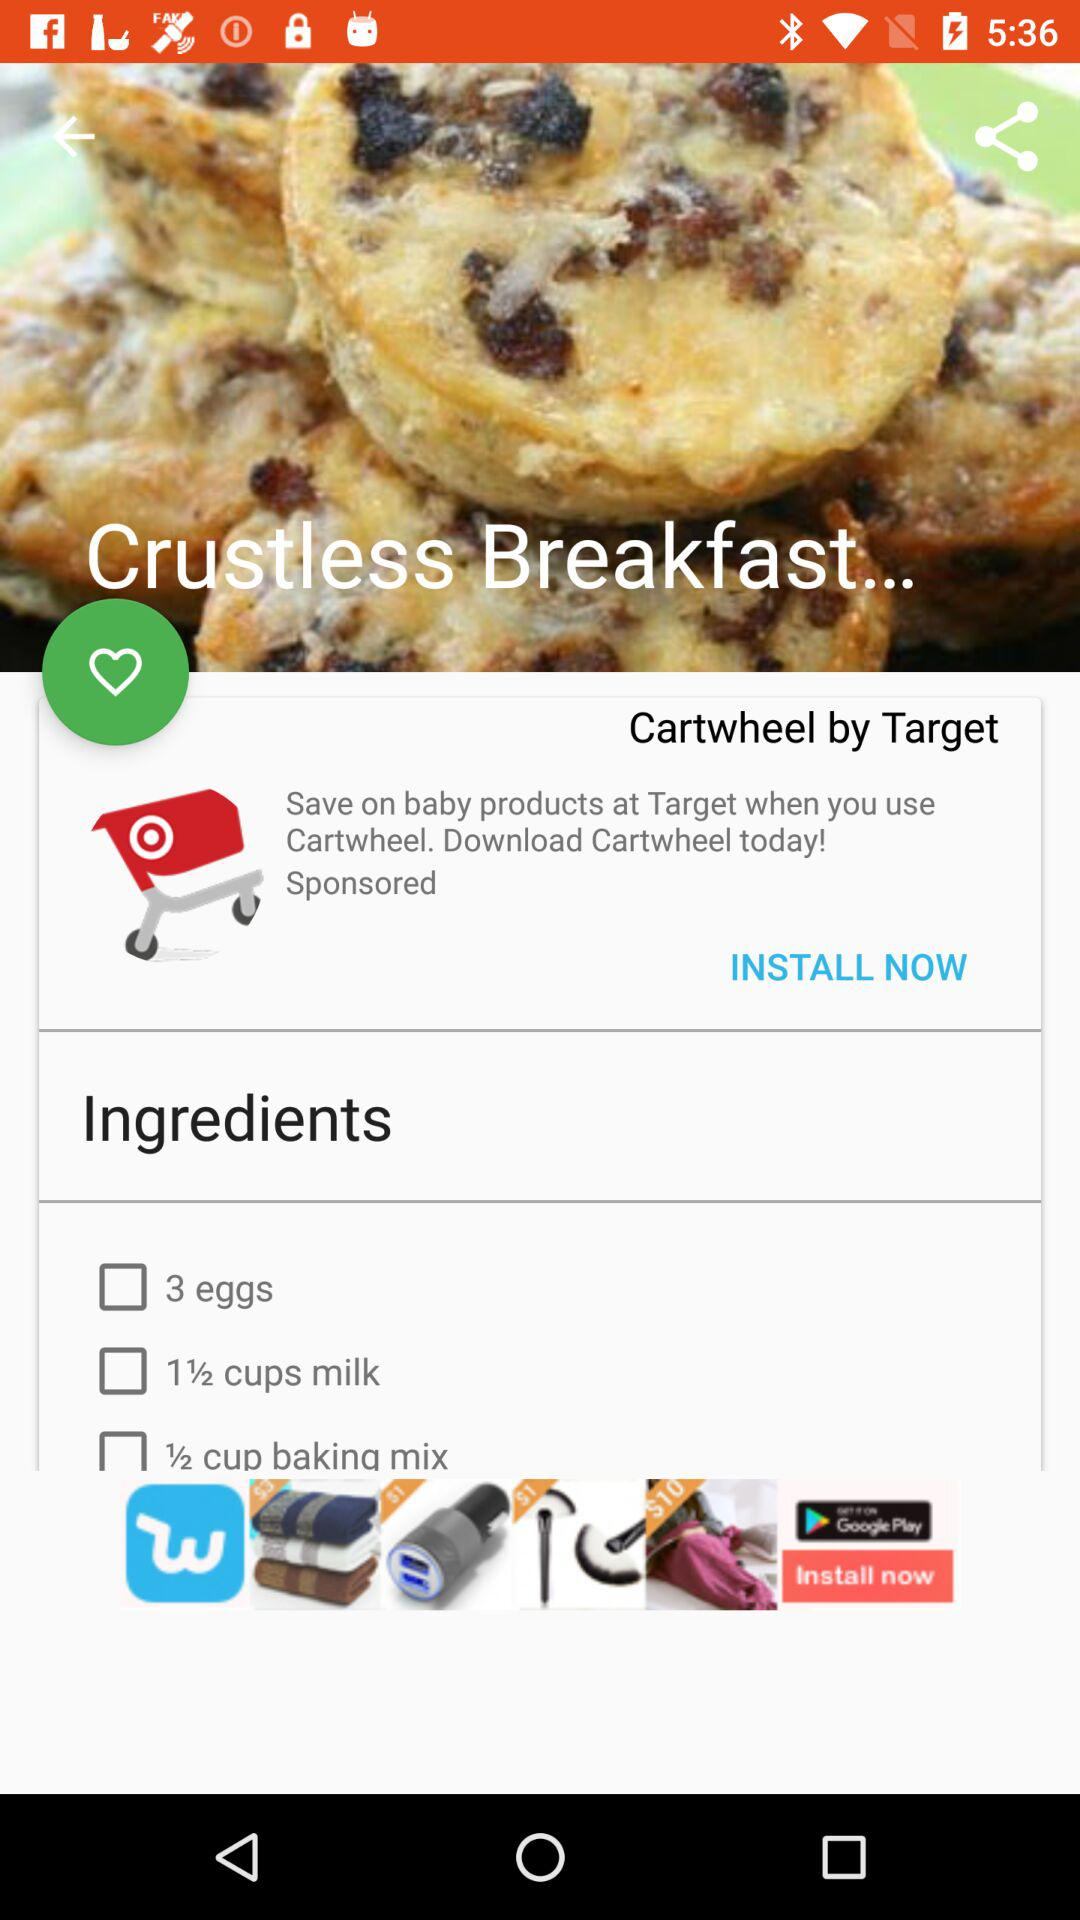What are the ingredients required for making "Crustless breakfast..."? The ingredients are "3 eggs", "1½ cups milk" and "½ cup baking mix". 